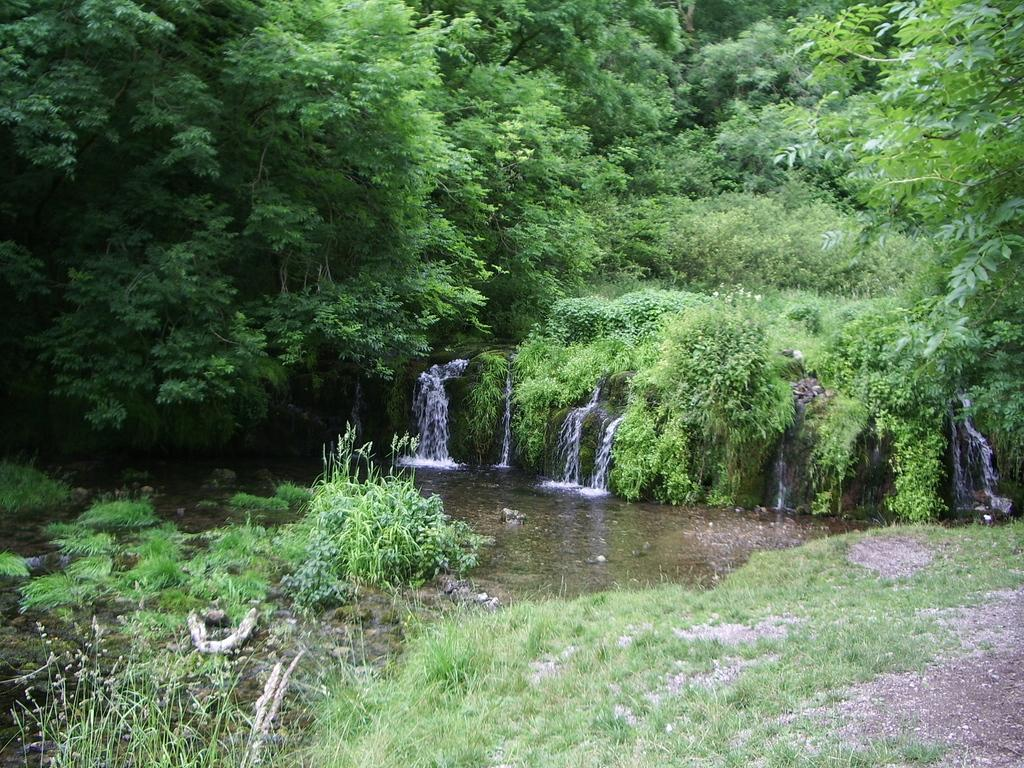What natural feature is the main subject of the image? There is a waterfall in the image. What type of vegetation can be seen in the image? There is grass and trees visible in the image. Are there any other plants in the image besides the trees? Yes, there is a plant in the image. What type of advertisement can be seen near the waterfall in the image? There is no advertisement present in the image; it features a waterfall, grass, trees, and a plant. Can you tell me how many pickles are growing on the plant in the image? There are no pickles present in the image; it features a plant that is not a pickle plant. 